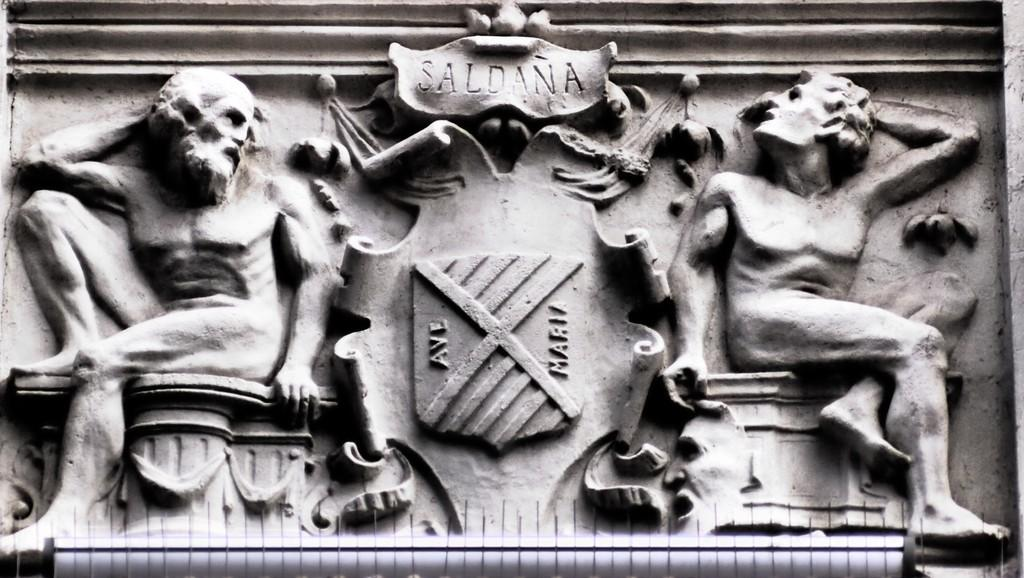<image>
Write a terse but informative summary of the picture. A stone carving of two men sitting with a banner reading saldana above. 